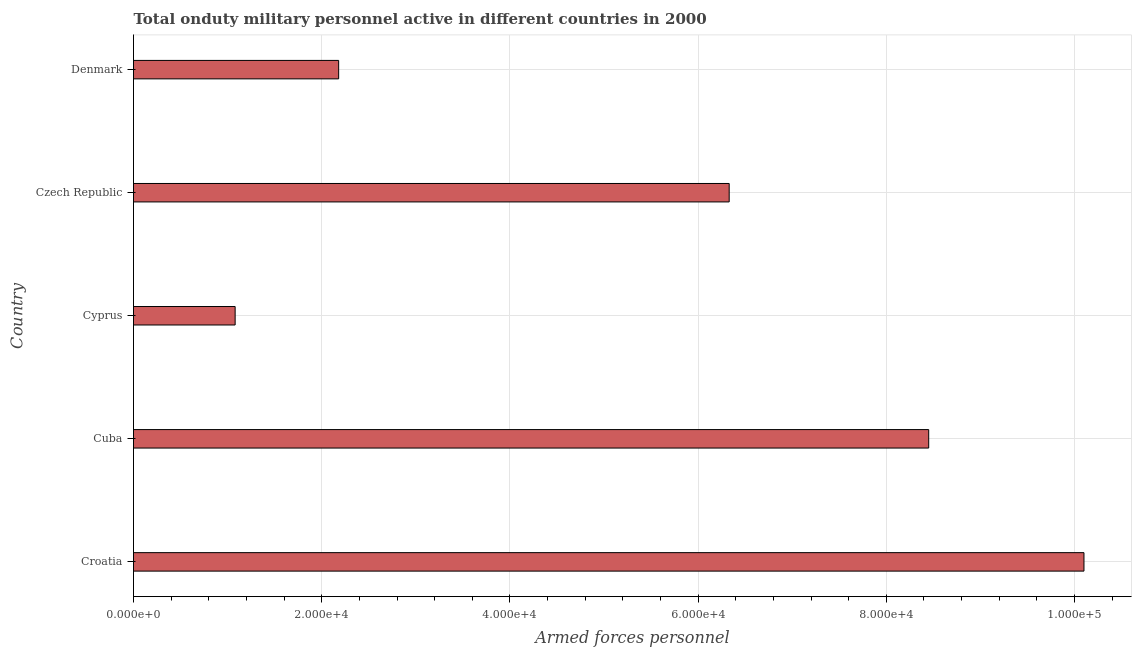Does the graph contain any zero values?
Ensure brevity in your answer.  No. What is the title of the graph?
Give a very brief answer. Total onduty military personnel active in different countries in 2000. What is the label or title of the X-axis?
Make the answer very short. Armed forces personnel. What is the number of armed forces personnel in Cyprus?
Offer a very short reply. 1.08e+04. Across all countries, what is the maximum number of armed forces personnel?
Your answer should be very brief. 1.01e+05. Across all countries, what is the minimum number of armed forces personnel?
Your response must be concise. 1.08e+04. In which country was the number of armed forces personnel maximum?
Your answer should be very brief. Croatia. In which country was the number of armed forces personnel minimum?
Provide a short and direct response. Cyprus. What is the sum of the number of armed forces personnel?
Your response must be concise. 2.81e+05. What is the difference between the number of armed forces personnel in Cyprus and Denmark?
Offer a terse response. -1.10e+04. What is the average number of armed forces personnel per country?
Offer a very short reply. 5.63e+04. What is the median number of armed forces personnel?
Ensure brevity in your answer.  6.33e+04. In how many countries, is the number of armed forces personnel greater than 8000 ?
Your answer should be very brief. 5. What is the ratio of the number of armed forces personnel in Croatia to that in Cuba?
Offer a very short reply. 1.2. Is the number of armed forces personnel in Cyprus less than that in Czech Republic?
Your response must be concise. Yes. What is the difference between the highest and the second highest number of armed forces personnel?
Provide a succinct answer. 1.65e+04. Is the sum of the number of armed forces personnel in Cyprus and Denmark greater than the maximum number of armed forces personnel across all countries?
Offer a terse response. No. What is the difference between the highest and the lowest number of armed forces personnel?
Make the answer very short. 9.02e+04. Are all the bars in the graph horizontal?
Your answer should be very brief. Yes. How many countries are there in the graph?
Provide a succinct answer. 5. What is the difference between two consecutive major ticks on the X-axis?
Your answer should be very brief. 2.00e+04. What is the Armed forces personnel of Croatia?
Give a very brief answer. 1.01e+05. What is the Armed forces personnel in Cuba?
Offer a terse response. 8.45e+04. What is the Armed forces personnel of Cyprus?
Offer a terse response. 1.08e+04. What is the Armed forces personnel of Czech Republic?
Keep it short and to the point. 6.33e+04. What is the Armed forces personnel in Denmark?
Ensure brevity in your answer.  2.18e+04. What is the difference between the Armed forces personnel in Croatia and Cuba?
Provide a succinct answer. 1.65e+04. What is the difference between the Armed forces personnel in Croatia and Cyprus?
Offer a very short reply. 9.02e+04. What is the difference between the Armed forces personnel in Croatia and Czech Republic?
Offer a terse response. 3.77e+04. What is the difference between the Armed forces personnel in Croatia and Denmark?
Keep it short and to the point. 7.92e+04. What is the difference between the Armed forces personnel in Cuba and Cyprus?
Your answer should be compact. 7.37e+04. What is the difference between the Armed forces personnel in Cuba and Czech Republic?
Provide a short and direct response. 2.12e+04. What is the difference between the Armed forces personnel in Cuba and Denmark?
Provide a succinct answer. 6.27e+04. What is the difference between the Armed forces personnel in Cyprus and Czech Republic?
Provide a short and direct response. -5.25e+04. What is the difference between the Armed forces personnel in Cyprus and Denmark?
Make the answer very short. -1.10e+04. What is the difference between the Armed forces personnel in Czech Republic and Denmark?
Your answer should be very brief. 4.15e+04. What is the ratio of the Armed forces personnel in Croatia to that in Cuba?
Provide a succinct answer. 1.2. What is the ratio of the Armed forces personnel in Croatia to that in Cyprus?
Provide a short and direct response. 9.35. What is the ratio of the Armed forces personnel in Croatia to that in Czech Republic?
Offer a terse response. 1.6. What is the ratio of the Armed forces personnel in Croatia to that in Denmark?
Offer a terse response. 4.63. What is the ratio of the Armed forces personnel in Cuba to that in Cyprus?
Your response must be concise. 7.82. What is the ratio of the Armed forces personnel in Cuba to that in Czech Republic?
Offer a very short reply. 1.33. What is the ratio of the Armed forces personnel in Cuba to that in Denmark?
Make the answer very short. 3.88. What is the ratio of the Armed forces personnel in Cyprus to that in Czech Republic?
Ensure brevity in your answer.  0.17. What is the ratio of the Armed forces personnel in Cyprus to that in Denmark?
Make the answer very short. 0.49. What is the ratio of the Armed forces personnel in Czech Republic to that in Denmark?
Give a very brief answer. 2.9. 